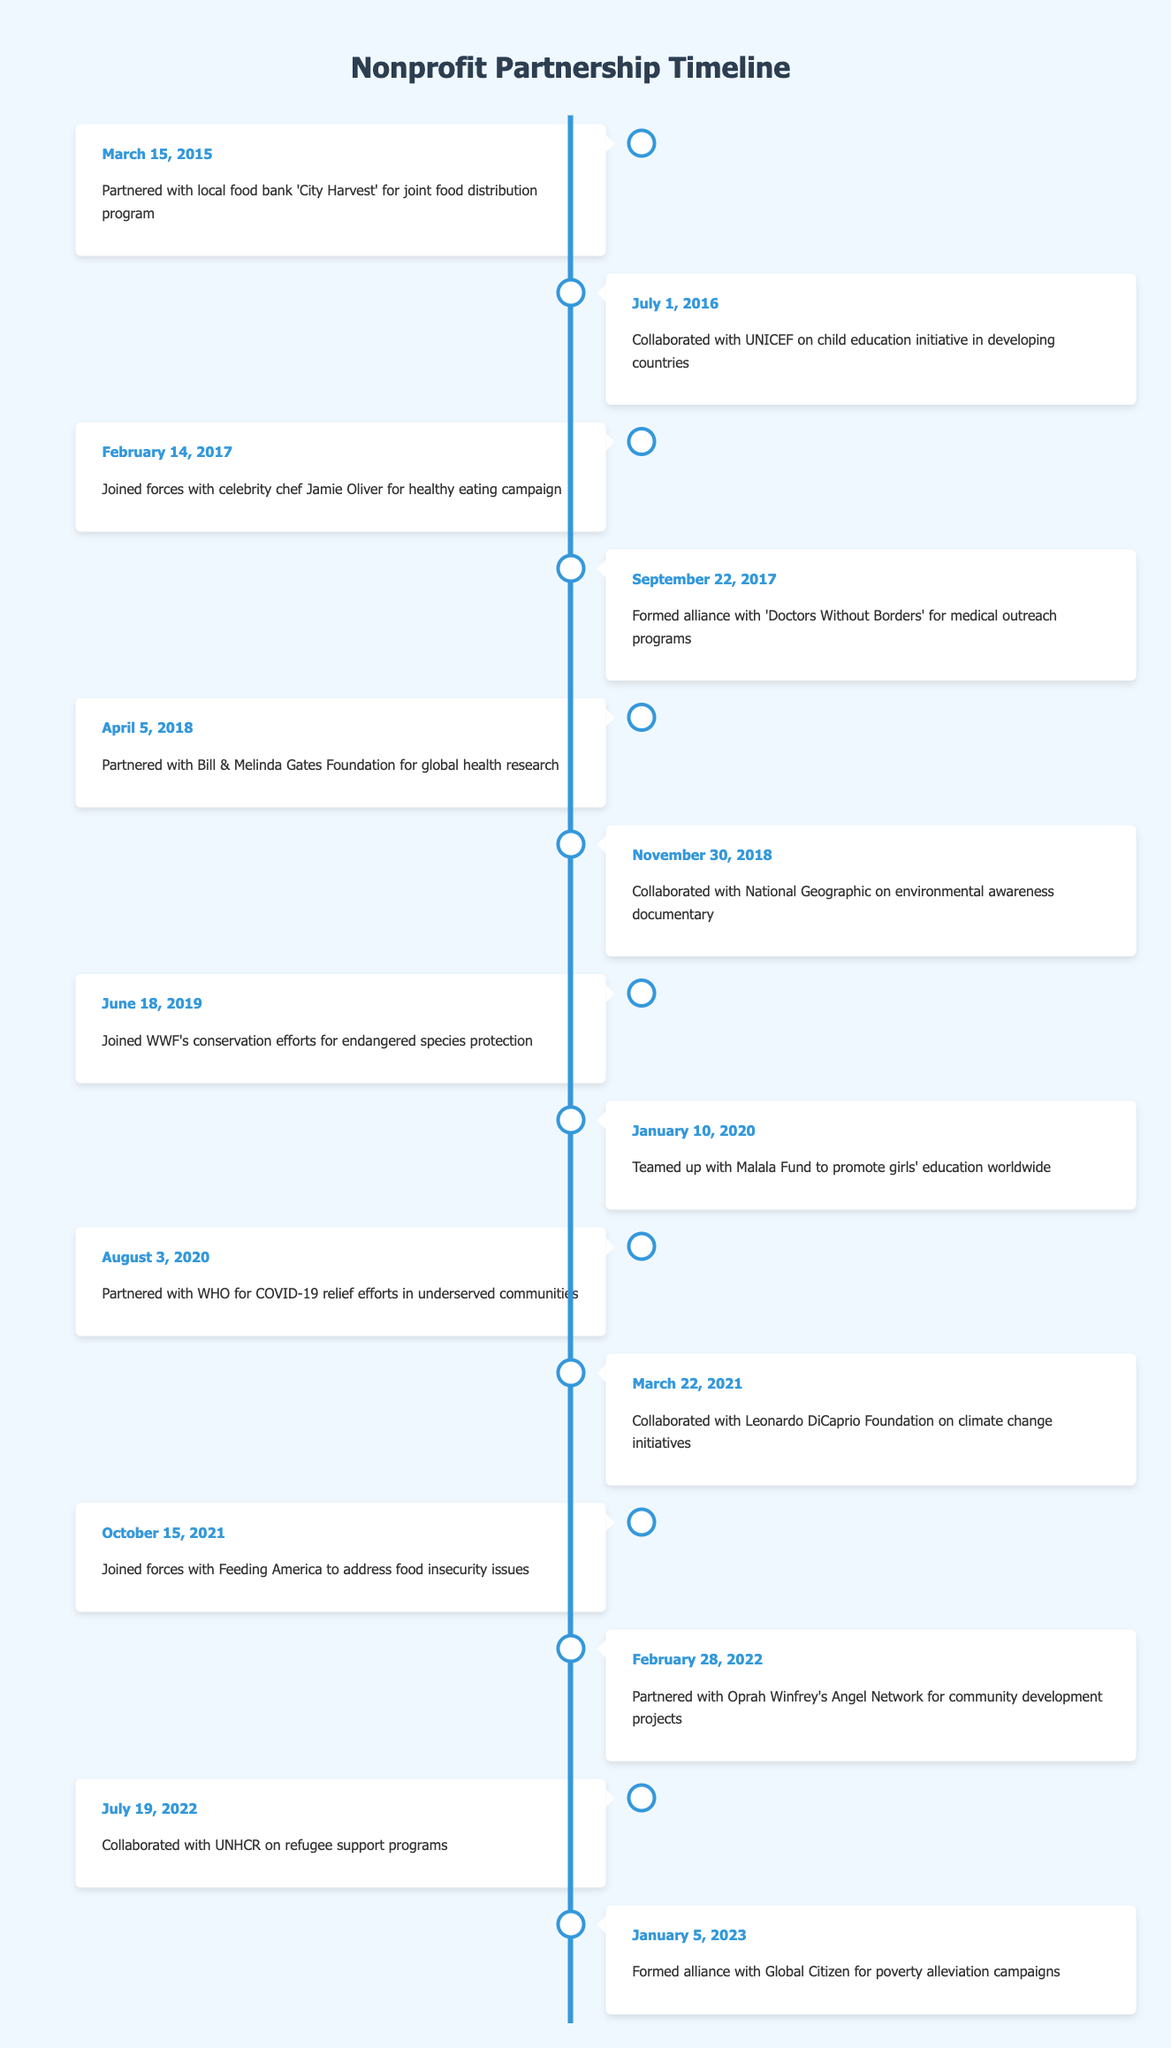What was the first partnership established? The first event listed in the timeline is "Partnered with local food bank 'City Harvest' for joint food distribution program," which occurred on March 15, 2015. This indicates it was the earliest partnership formed.
Answer: March 15, 2015 How many partnerships were formed in 2018? In 2018, there are two partnerships recorded: one with the Bill & Melinda Gates Foundation on April 5, and another with National Geographic on November 30. Thus, counting them gives us a total of two.
Answer: 2 Was there a partnership formed in 2021? The timeline includes two events for the year 2021: one with the Leonardo DiCaprio Foundation on March 22, and another with Feeding America on October 15. Therefore, it confirms there were partnerships in that year.
Answer: Yes Which partnership focused on environmental issues? Two partnerships focused on environmental issues: one with National Geographic on November 30, 2018, for an environmental awareness documentary and another with the Leonardo DiCaprio Foundation on March 22, 2021, for climate change initiatives.
Answer: Two When was the collaboration with the Malala Fund formed? According to the timeline, the partnership with the Malala Fund occurred on January 10, 2020. This provides a specific date for this collaboration.
Answer: January 10, 2020 What is the chronological gap between the first and last recorded partnerships? The first recorded partnership was on March 15, 2015, and the last one was on January 5, 2023. To find the gap, we calculate the time difference: from March 15, 2015, to March 15, 2022, is 7 years, and from that date to January 5, 2023, is approximately 9 months and 20 days. Therefore, the total gap is about 7 years and 9 months.
Answer: 7 years and 9 months Did the organization collaborate with any celebrities? Yes, there are two recorded collaborations with celebrities: one with celebrity chef Jamie Oliver on February 14, 2017, and another with Oprah Winfrey's Angel Network on February 28, 2022. This affirms the involvement of famous individuals in the partnerships.
Answer: Yes What partnership specifically targeted COVID-19 relief efforts? The exact partnership that focused solely on COVID-19 relief efforts is listed as the one with WHO on August 3, 2020. This entry clearly identifies the purpose of the collaboration.
Answer: WHO on August 3, 2020 Which organization was involved in a food distribution program? The partnership with 'City Harvest' on March 15, 2015, specifically addresses a joint food distribution program. This provides a direct answer regarding the focus of the collaboration.
Answer: City Harvest on March 15, 2015 